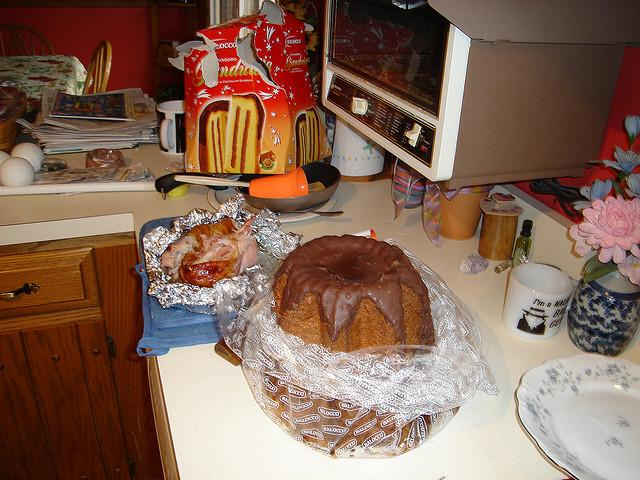What is the cake on top of? Please explain your reasoning. counter. Counters are found in the kitchen where the cake would be. 